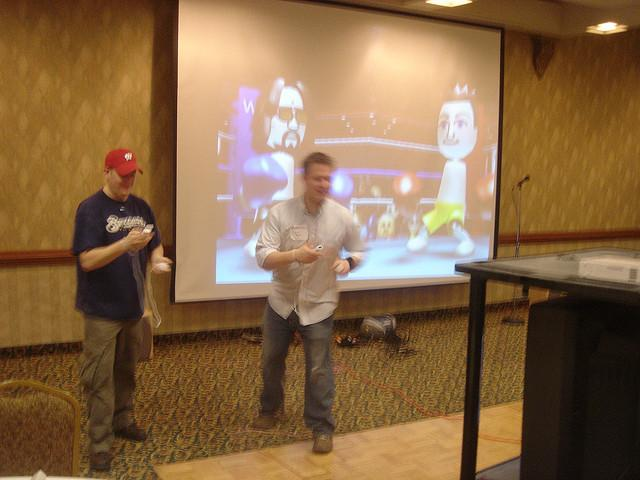Which player is controlling the avatar with the blue gloves? Please explain your reasoning. black shirt. Black shirt guy is on the left just like the blue character. 